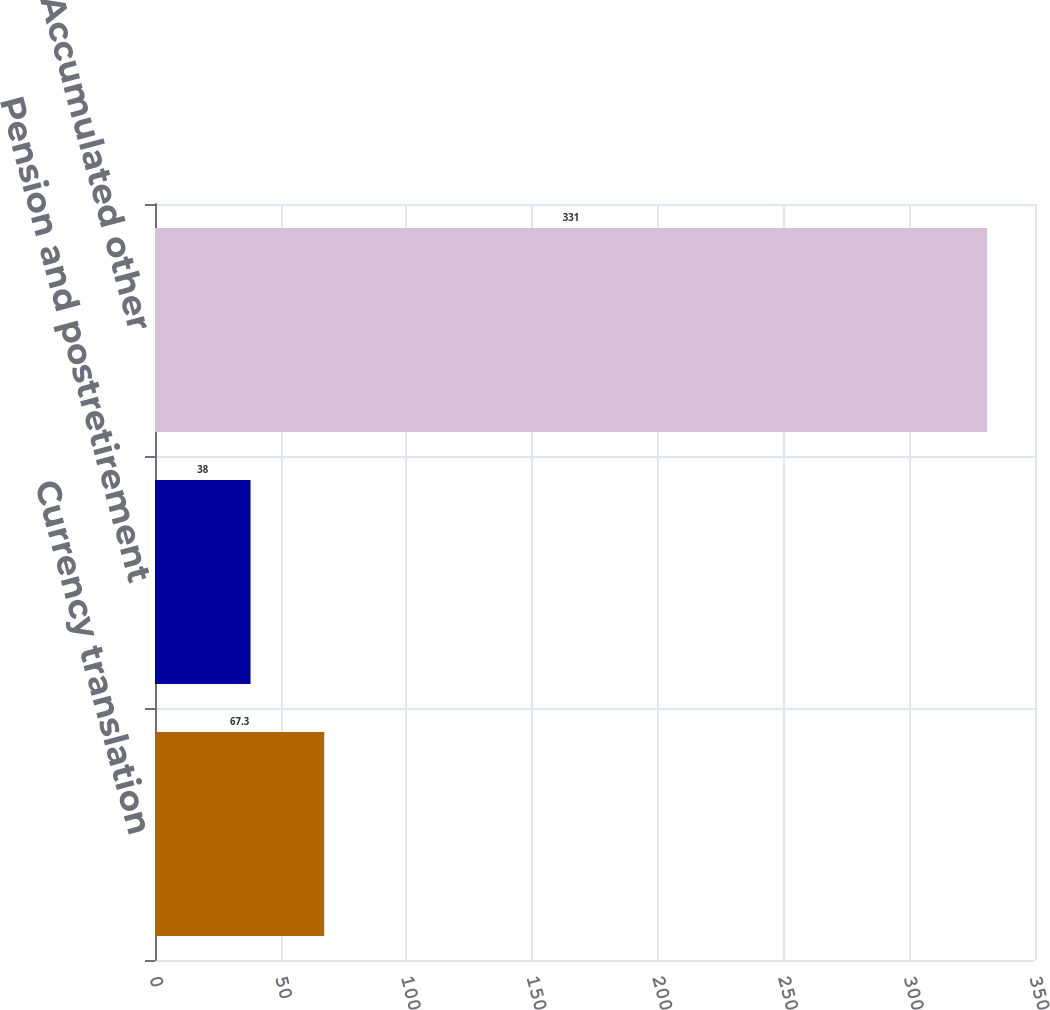<chart> <loc_0><loc_0><loc_500><loc_500><bar_chart><fcel>Currency translation<fcel>Pension and postretirement<fcel>Accumulated other<nl><fcel>67.3<fcel>38<fcel>331<nl></chart> 